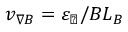<formula> <loc_0><loc_0><loc_500><loc_500>v _ { \nabla B } = \varepsilon _ { \perp } / B L _ { B }</formula> 